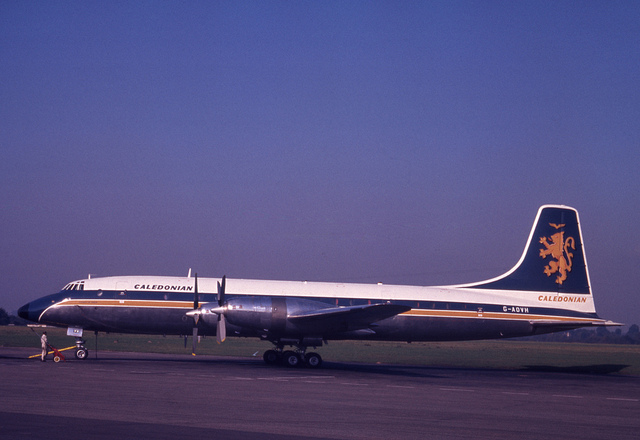<image>Where is this plane flying to? I don't know where the plane is flying to. It can be 'caledonian', 'usa', 'spain', 'caledonia', 'california' or 'paris'. Where is this plane going? It is unknown where the plane is going. It could be going to several places such as California, USA, Scotland, or Britain. Where is this plane going? I don't know where this plane is going. It can be anywhere from California to Scotland. Where is this plane flying to? I am not sure where this plane is flying to. It can be flying to Caledonian, USA, Spain, California, or Paris. 